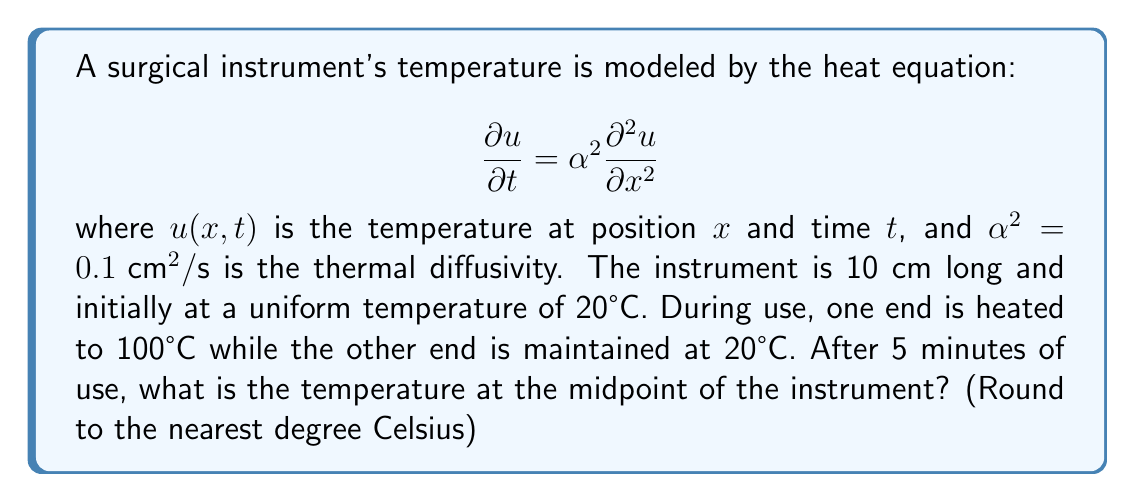Give your solution to this math problem. To solve this problem, we need to use the steady-state solution of the heat equation, as 5 minutes is likely enough time for the temperature distribution to reach equilibrium. The steady-state solution is linear for this scenario:

1) The steady-state solution is of the form:
   $$u(x) = Ax + B$$

2) Boundary conditions:
   At $x = 0$, $u(0) = 100°C$
   At $x = 10$, $u(10) = 20°C$

3) Applying these conditions:
   $$100 = B$$
   $$20 = 10A + 100$$

4) Solving for $A$:
   $$20 - 100 = 10A$$
   $$A = -8$$

5) The steady-state solution is:
   $$u(x) = -8x + 100$$

6) The midpoint is at $x = 5$ cm. Calculating the temperature:
   $$u(5) = -8(5) + 100 = -40 + 100 = 60°C$$

Therefore, after 5 minutes, the temperature at the midpoint of the instrument is approximately 60°C.
Answer: 60°C 